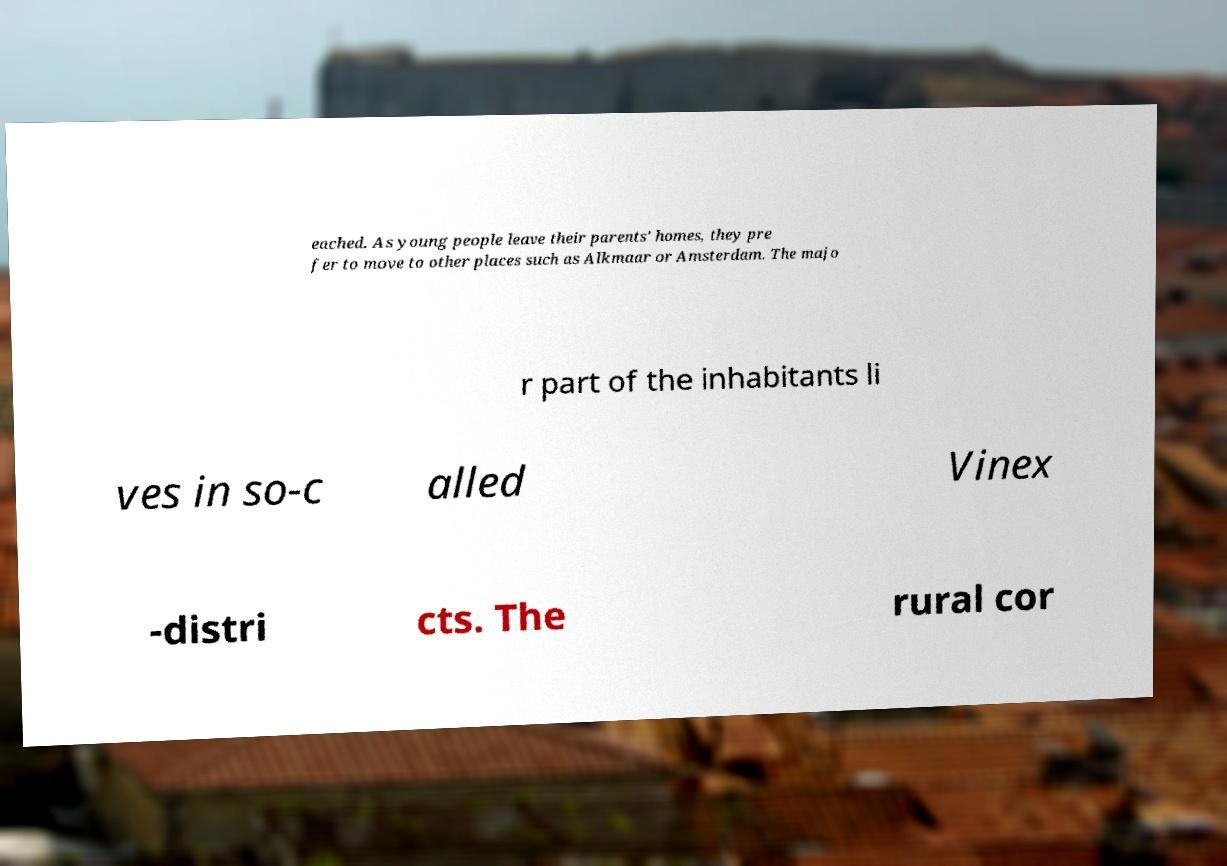Could you assist in decoding the text presented in this image and type it out clearly? eached. As young people leave their parents' homes, they pre fer to move to other places such as Alkmaar or Amsterdam. The majo r part of the inhabitants li ves in so-c alled Vinex -distri cts. The rural cor 